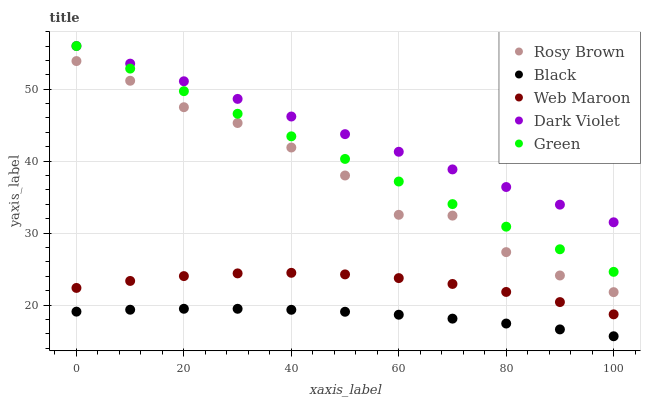Does Black have the minimum area under the curve?
Answer yes or no. Yes. Does Dark Violet have the maximum area under the curve?
Answer yes or no. Yes. Does Rosy Brown have the minimum area under the curve?
Answer yes or no. No. Does Rosy Brown have the maximum area under the curve?
Answer yes or no. No. Is Green the smoothest?
Answer yes or no. Yes. Is Rosy Brown the roughest?
Answer yes or no. Yes. Is Black the smoothest?
Answer yes or no. No. Is Black the roughest?
Answer yes or no. No. Does Black have the lowest value?
Answer yes or no. Yes. Does Rosy Brown have the lowest value?
Answer yes or no. No. Does Dark Violet have the highest value?
Answer yes or no. Yes. Does Rosy Brown have the highest value?
Answer yes or no. No. Is Web Maroon less than Dark Violet?
Answer yes or no. Yes. Is Dark Violet greater than Web Maroon?
Answer yes or no. Yes. Does Green intersect Dark Violet?
Answer yes or no. Yes. Is Green less than Dark Violet?
Answer yes or no. No. Is Green greater than Dark Violet?
Answer yes or no. No. Does Web Maroon intersect Dark Violet?
Answer yes or no. No. 